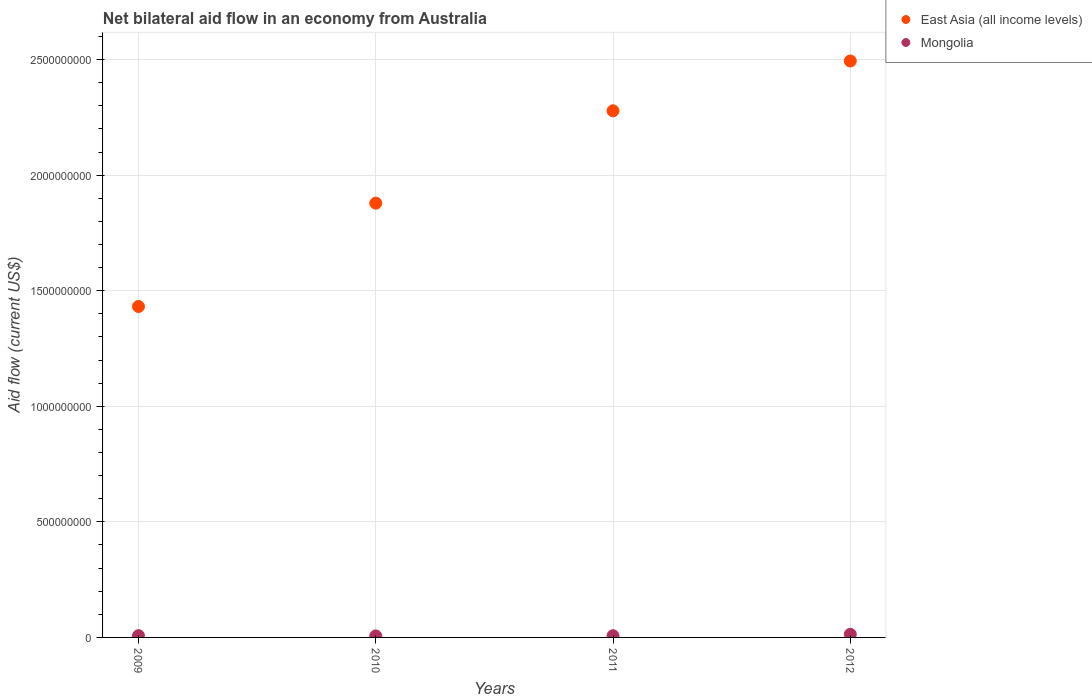How many different coloured dotlines are there?
Your answer should be very brief. 2. What is the net bilateral aid flow in Mongolia in 2012?
Offer a terse response. 1.35e+07. Across all years, what is the maximum net bilateral aid flow in Mongolia?
Offer a terse response. 1.35e+07. Across all years, what is the minimum net bilateral aid flow in East Asia (all income levels)?
Ensure brevity in your answer.  1.43e+09. In which year was the net bilateral aid flow in Mongolia minimum?
Your answer should be very brief. 2010. What is the total net bilateral aid flow in Mongolia in the graph?
Make the answer very short. 3.52e+07. What is the difference between the net bilateral aid flow in Mongolia in 2009 and that in 2012?
Provide a succinct answer. -5.89e+06. What is the difference between the net bilateral aid flow in East Asia (all income levels) in 2010 and the net bilateral aid flow in Mongolia in 2012?
Offer a terse response. 1.87e+09. What is the average net bilateral aid flow in Mongolia per year?
Make the answer very short. 8.81e+06. In the year 2011, what is the difference between the net bilateral aid flow in Mongolia and net bilateral aid flow in East Asia (all income levels)?
Your answer should be compact. -2.27e+09. What is the ratio of the net bilateral aid flow in Mongolia in 2010 to that in 2012?
Keep it short and to the point. 0.49. Is the difference between the net bilateral aid flow in Mongolia in 2009 and 2011 greater than the difference between the net bilateral aid flow in East Asia (all income levels) in 2009 and 2011?
Your answer should be very brief. Yes. What is the difference between the highest and the second highest net bilateral aid flow in Mongolia?
Provide a short and direct response. 5.89e+06. What is the difference between the highest and the lowest net bilateral aid flow in East Asia (all income levels)?
Your answer should be compact. 1.06e+09. In how many years, is the net bilateral aid flow in Mongolia greater than the average net bilateral aid flow in Mongolia taken over all years?
Offer a very short reply. 1. Is the sum of the net bilateral aid flow in East Asia (all income levels) in 2011 and 2012 greater than the maximum net bilateral aid flow in Mongolia across all years?
Make the answer very short. Yes. Is the net bilateral aid flow in Mongolia strictly less than the net bilateral aid flow in East Asia (all income levels) over the years?
Your answer should be compact. Yes. How many dotlines are there?
Keep it short and to the point. 2. What is the difference between two consecutive major ticks on the Y-axis?
Provide a short and direct response. 5.00e+08. Are the values on the major ticks of Y-axis written in scientific E-notation?
Your answer should be very brief. No. Does the graph contain any zero values?
Keep it short and to the point. No. Does the graph contain grids?
Your answer should be compact. Yes. Where does the legend appear in the graph?
Ensure brevity in your answer.  Top right. How many legend labels are there?
Your response must be concise. 2. How are the legend labels stacked?
Offer a very short reply. Vertical. What is the title of the graph?
Make the answer very short. Net bilateral aid flow in an economy from Australia. What is the label or title of the X-axis?
Provide a succinct answer. Years. What is the label or title of the Y-axis?
Make the answer very short. Aid flow (current US$). What is the Aid flow (current US$) of East Asia (all income levels) in 2009?
Ensure brevity in your answer.  1.43e+09. What is the Aid flow (current US$) in Mongolia in 2009?
Make the answer very short. 7.65e+06. What is the Aid flow (current US$) of East Asia (all income levels) in 2010?
Your response must be concise. 1.88e+09. What is the Aid flow (current US$) of Mongolia in 2010?
Ensure brevity in your answer.  6.64e+06. What is the Aid flow (current US$) in East Asia (all income levels) in 2011?
Ensure brevity in your answer.  2.28e+09. What is the Aid flow (current US$) in Mongolia in 2011?
Make the answer very short. 7.42e+06. What is the Aid flow (current US$) of East Asia (all income levels) in 2012?
Offer a very short reply. 2.49e+09. What is the Aid flow (current US$) of Mongolia in 2012?
Ensure brevity in your answer.  1.35e+07. Across all years, what is the maximum Aid flow (current US$) in East Asia (all income levels)?
Provide a succinct answer. 2.49e+09. Across all years, what is the maximum Aid flow (current US$) in Mongolia?
Ensure brevity in your answer.  1.35e+07. Across all years, what is the minimum Aid flow (current US$) in East Asia (all income levels)?
Your response must be concise. 1.43e+09. Across all years, what is the minimum Aid flow (current US$) in Mongolia?
Offer a very short reply. 6.64e+06. What is the total Aid flow (current US$) in East Asia (all income levels) in the graph?
Provide a succinct answer. 8.08e+09. What is the total Aid flow (current US$) of Mongolia in the graph?
Your answer should be compact. 3.52e+07. What is the difference between the Aid flow (current US$) of East Asia (all income levels) in 2009 and that in 2010?
Ensure brevity in your answer.  -4.47e+08. What is the difference between the Aid flow (current US$) of Mongolia in 2009 and that in 2010?
Provide a succinct answer. 1.01e+06. What is the difference between the Aid flow (current US$) of East Asia (all income levels) in 2009 and that in 2011?
Give a very brief answer. -8.47e+08. What is the difference between the Aid flow (current US$) in Mongolia in 2009 and that in 2011?
Your answer should be compact. 2.30e+05. What is the difference between the Aid flow (current US$) in East Asia (all income levels) in 2009 and that in 2012?
Your response must be concise. -1.06e+09. What is the difference between the Aid flow (current US$) of Mongolia in 2009 and that in 2012?
Give a very brief answer. -5.89e+06. What is the difference between the Aid flow (current US$) of East Asia (all income levels) in 2010 and that in 2011?
Provide a short and direct response. -4.00e+08. What is the difference between the Aid flow (current US$) of Mongolia in 2010 and that in 2011?
Your response must be concise. -7.80e+05. What is the difference between the Aid flow (current US$) in East Asia (all income levels) in 2010 and that in 2012?
Keep it short and to the point. -6.15e+08. What is the difference between the Aid flow (current US$) in Mongolia in 2010 and that in 2012?
Offer a terse response. -6.90e+06. What is the difference between the Aid flow (current US$) of East Asia (all income levels) in 2011 and that in 2012?
Offer a terse response. -2.16e+08. What is the difference between the Aid flow (current US$) of Mongolia in 2011 and that in 2012?
Your answer should be compact. -6.12e+06. What is the difference between the Aid flow (current US$) in East Asia (all income levels) in 2009 and the Aid flow (current US$) in Mongolia in 2010?
Give a very brief answer. 1.43e+09. What is the difference between the Aid flow (current US$) in East Asia (all income levels) in 2009 and the Aid flow (current US$) in Mongolia in 2011?
Your answer should be compact. 1.42e+09. What is the difference between the Aid flow (current US$) of East Asia (all income levels) in 2009 and the Aid flow (current US$) of Mongolia in 2012?
Provide a succinct answer. 1.42e+09. What is the difference between the Aid flow (current US$) in East Asia (all income levels) in 2010 and the Aid flow (current US$) in Mongolia in 2011?
Provide a succinct answer. 1.87e+09. What is the difference between the Aid flow (current US$) in East Asia (all income levels) in 2010 and the Aid flow (current US$) in Mongolia in 2012?
Your answer should be very brief. 1.87e+09. What is the difference between the Aid flow (current US$) of East Asia (all income levels) in 2011 and the Aid flow (current US$) of Mongolia in 2012?
Keep it short and to the point. 2.26e+09. What is the average Aid flow (current US$) in East Asia (all income levels) per year?
Offer a terse response. 2.02e+09. What is the average Aid flow (current US$) of Mongolia per year?
Keep it short and to the point. 8.81e+06. In the year 2009, what is the difference between the Aid flow (current US$) of East Asia (all income levels) and Aid flow (current US$) of Mongolia?
Ensure brevity in your answer.  1.42e+09. In the year 2010, what is the difference between the Aid flow (current US$) in East Asia (all income levels) and Aid flow (current US$) in Mongolia?
Give a very brief answer. 1.87e+09. In the year 2011, what is the difference between the Aid flow (current US$) of East Asia (all income levels) and Aid flow (current US$) of Mongolia?
Keep it short and to the point. 2.27e+09. In the year 2012, what is the difference between the Aid flow (current US$) in East Asia (all income levels) and Aid flow (current US$) in Mongolia?
Your answer should be compact. 2.48e+09. What is the ratio of the Aid flow (current US$) of East Asia (all income levels) in 2009 to that in 2010?
Your response must be concise. 0.76. What is the ratio of the Aid flow (current US$) in Mongolia in 2009 to that in 2010?
Your answer should be very brief. 1.15. What is the ratio of the Aid flow (current US$) in East Asia (all income levels) in 2009 to that in 2011?
Give a very brief answer. 0.63. What is the ratio of the Aid flow (current US$) of Mongolia in 2009 to that in 2011?
Your response must be concise. 1.03. What is the ratio of the Aid flow (current US$) in East Asia (all income levels) in 2009 to that in 2012?
Your response must be concise. 0.57. What is the ratio of the Aid flow (current US$) in Mongolia in 2009 to that in 2012?
Your answer should be compact. 0.56. What is the ratio of the Aid flow (current US$) in East Asia (all income levels) in 2010 to that in 2011?
Keep it short and to the point. 0.82. What is the ratio of the Aid flow (current US$) of Mongolia in 2010 to that in 2011?
Offer a terse response. 0.89. What is the ratio of the Aid flow (current US$) of East Asia (all income levels) in 2010 to that in 2012?
Make the answer very short. 0.75. What is the ratio of the Aid flow (current US$) in Mongolia in 2010 to that in 2012?
Give a very brief answer. 0.49. What is the ratio of the Aid flow (current US$) in East Asia (all income levels) in 2011 to that in 2012?
Provide a short and direct response. 0.91. What is the ratio of the Aid flow (current US$) in Mongolia in 2011 to that in 2012?
Provide a short and direct response. 0.55. What is the difference between the highest and the second highest Aid flow (current US$) in East Asia (all income levels)?
Keep it short and to the point. 2.16e+08. What is the difference between the highest and the second highest Aid flow (current US$) in Mongolia?
Keep it short and to the point. 5.89e+06. What is the difference between the highest and the lowest Aid flow (current US$) of East Asia (all income levels)?
Ensure brevity in your answer.  1.06e+09. What is the difference between the highest and the lowest Aid flow (current US$) of Mongolia?
Your response must be concise. 6.90e+06. 